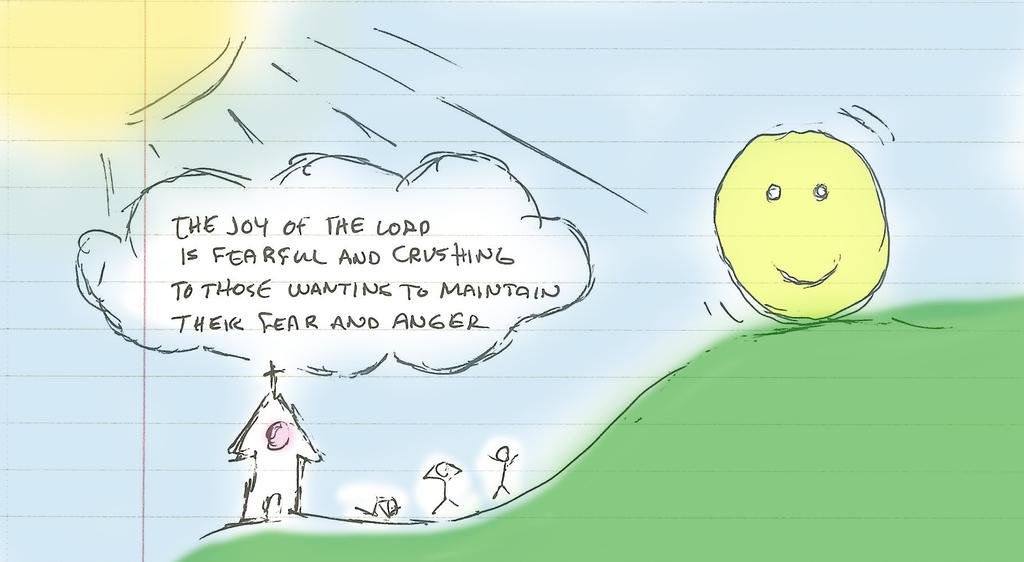What is depicted on the paper in the image? There is a painting on the paper in the image. Is there any text on the paper? Yes, there is handwritten text in the middle of the paper. What type of coach can be seen in the image? There is no coach present in the image; it only features a paper with a painting and handwritten text. How many men are visible in the image? There are no men present in the image; it only features a paper with a painting and handwritten text. 